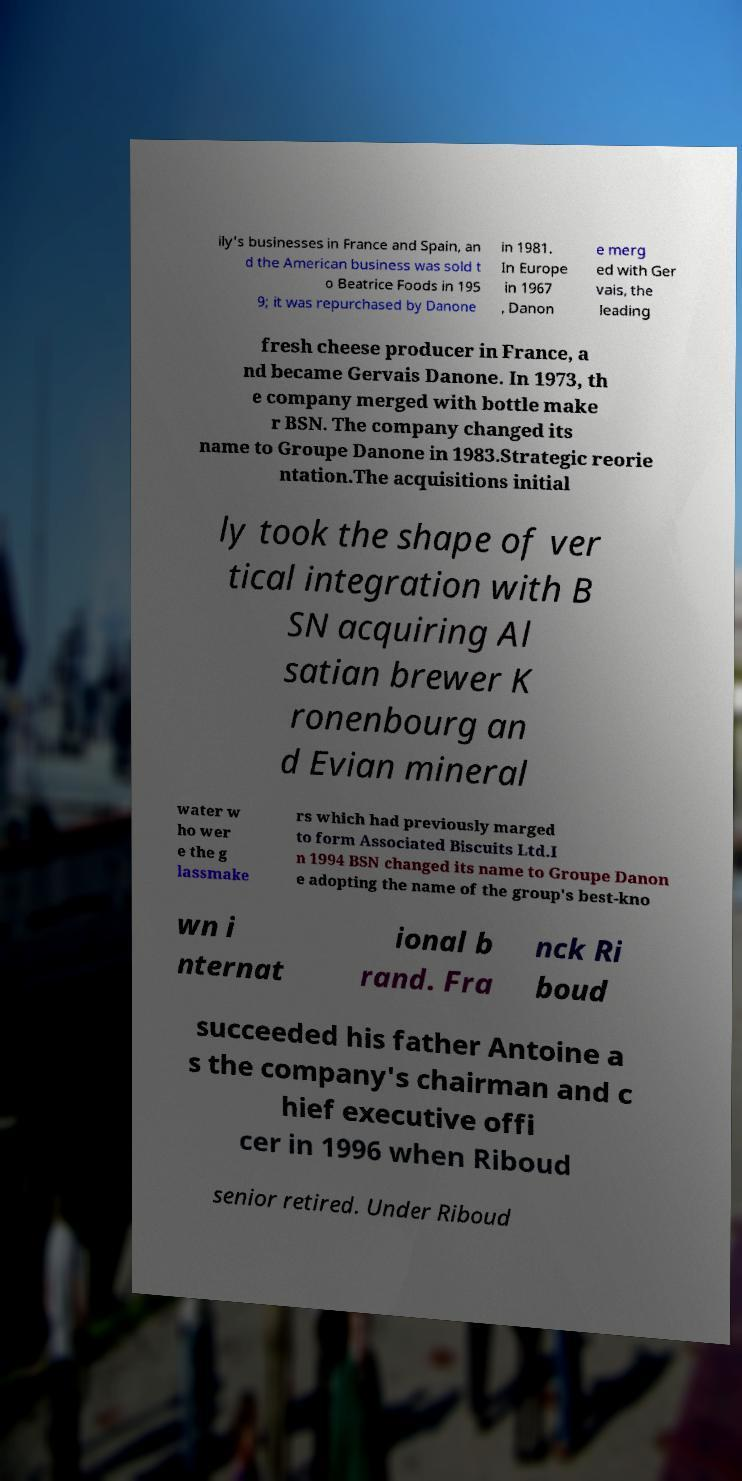Can you accurately transcribe the text from the provided image for me? ily's businesses in France and Spain, an d the American business was sold t o Beatrice Foods in 195 9; it was repurchased by Danone in 1981. In Europe in 1967 , Danon e merg ed with Ger vais, the leading fresh cheese producer in France, a nd became Gervais Danone. In 1973, th e company merged with bottle make r BSN. The company changed its name to Groupe Danone in 1983.Strategic reorie ntation.The acquisitions initial ly took the shape of ver tical integration with B SN acquiring Al satian brewer K ronenbourg an d Evian mineral water w ho wer e the g lassmake rs which had previously marged to form Associated Biscuits Ltd.I n 1994 BSN changed its name to Groupe Danon e adopting the name of the group's best-kno wn i nternat ional b rand. Fra nck Ri boud succeeded his father Antoine a s the company's chairman and c hief executive offi cer in 1996 when Riboud senior retired. Under Riboud 